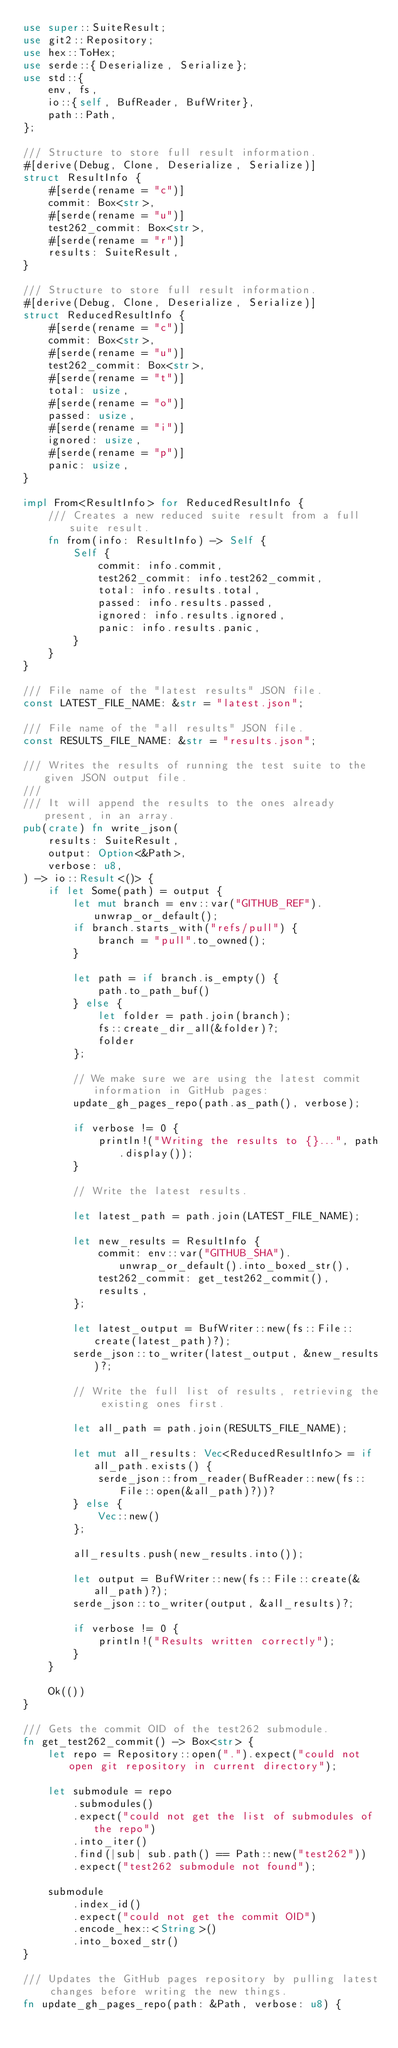<code> <loc_0><loc_0><loc_500><loc_500><_Rust_>use super::SuiteResult;
use git2::Repository;
use hex::ToHex;
use serde::{Deserialize, Serialize};
use std::{
    env, fs,
    io::{self, BufReader, BufWriter},
    path::Path,
};

/// Structure to store full result information.
#[derive(Debug, Clone, Deserialize, Serialize)]
struct ResultInfo {
    #[serde(rename = "c")]
    commit: Box<str>,
    #[serde(rename = "u")]
    test262_commit: Box<str>,
    #[serde(rename = "r")]
    results: SuiteResult,
}

/// Structure to store full result information.
#[derive(Debug, Clone, Deserialize, Serialize)]
struct ReducedResultInfo {
    #[serde(rename = "c")]
    commit: Box<str>,
    #[serde(rename = "u")]
    test262_commit: Box<str>,
    #[serde(rename = "t")]
    total: usize,
    #[serde(rename = "o")]
    passed: usize,
    #[serde(rename = "i")]
    ignored: usize,
    #[serde(rename = "p")]
    panic: usize,
}

impl From<ResultInfo> for ReducedResultInfo {
    /// Creates a new reduced suite result from a full suite result.
    fn from(info: ResultInfo) -> Self {
        Self {
            commit: info.commit,
            test262_commit: info.test262_commit,
            total: info.results.total,
            passed: info.results.passed,
            ignored: info.results.ignored,
            panic: info.results.panic,
        }
    }
}

/// File name of the "latest results" JSON file.
const LATEST_FILE_NAME: &str = "latest.json";

/// File name of the "all results" JSON file.
const RESULTS_FILE_NAME: &str = "results.json";

/// Writes the results of running the test suite to the given JSON output file.
///
/// It will append the results to the ones already present, in an array.
pub(crate) fn write_json(
    results: SuiteResult,
    output: Option<&Path>,
    verbose: u8,
) -> io::Result<()> {
    if let Some(path) = output {
        let mut branch = env::var("GITHUB_REF").unwrap_or_default();
        if branch.starts_with("refs/pull") {
            branch = "pull".to_owned();
        }

        let path = if branch.is_empty() {
            path.to_path_buf()
        } else {
            let folder = path.join(branch);
            fs::create_dir_all(&folder)?;
            folder
        };

        // We make sure we are using the latest commit information in GitHub pages:
        update_gh_pages_repo(path.as_path(), verbose);

        if verbose != 0 {
            println!("Writing the results to {}...", path.display());
        }

        // Write the latest results.

        let latest_path = path.join(LATEST_FILE_NAME);

        let new_results = ResultInfo {
            commit: env::var("GITHUB_SHA").unwrap_or_default().into_boxed_str(),
            test262_commit: get_test262_commit(),
            results,
        };

        let latest_output = BufWriter::new(fs::File::create(latest_path)?);
        serde_json::to_writer(latest_output, &new_results)?;

        // Write the full list of results, retrieving the existing ones first.

        let all_path = path.join(RESULTS_FILE_NAME);

        let mut all_results: Vec<ReducedResultInfo> = if all_path.exists() {
            serde_json::from_reader(BufReader::new(fs::File::open(&all_path)?))?
        } else {
            Vec::new()
        };

        all_results.push(new_results.into());

        let output = BufWriter::new(fs::File::create(&all_path)?);
        serde_json::to_writer(output, &all_results)?;

        if verbose != 0 {
            println!("Results written correctly");
        }
    }

    Ok(())
}

/// Gets the commit OID of the test262 submodule.
fn get_test262_commit() -> Box<str> {
    let repo = Repository::open(".").expect("could not open git repository in current directory");

    let submodule = repo
        .submodules()
        .expect("could not get the list of submodules of the repo")
        .into_iter()
        .find(|sub| sub.path() == Path::new("test262"))
        .expect("test262 submodule not found");

    submodule
        .index_id()
        .expect("could not get the commit OID")
        .encode_hex::<String>()
        .into_boxed_str()
}

/// Updates the GitHub pages repository by pulling latest changes before writing the new things.
fn update_gh_pages_repo(path: &Path, verbose: u8) {</code> 